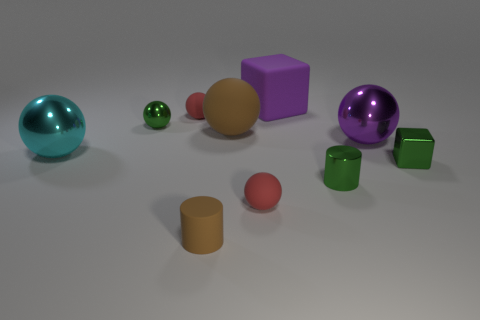Subtract 3 spheres. How many spheres are left? 3 Subtract all brown spheres. How many spheres are left? 5 Subtract all big cyan balls. How many balls are left? 5 Subtract all gray balls. Subtract all yellow blocks. How many balls are left? 6 Subtract all balls. How many objects are left? 4 Add 1 tiny spheres. How many tiny spheres are left? 4 Add 7 small green cubes. How many small green cubes exist? 8 Subtract 0 cyan cubes. How many objects are left? 10 Subtract all large metallic balls. Subtract all small green metallic cylinders. How many objects are left? 7 